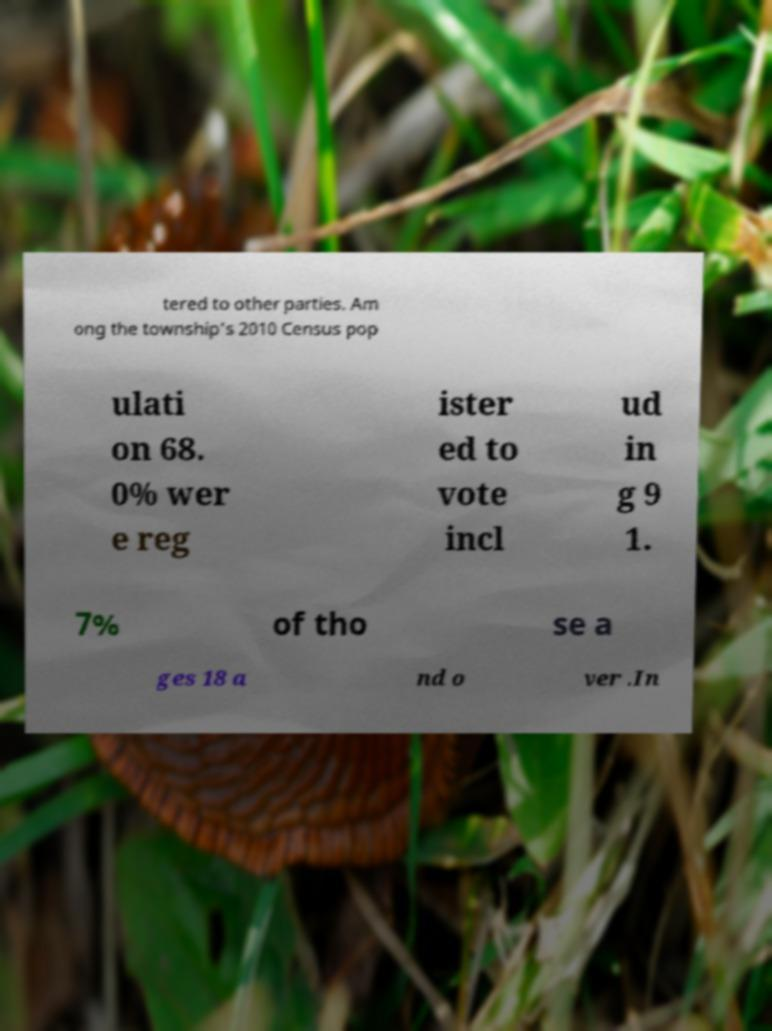Can you accurately transcribe the text from the provided image for me? tered to other parties. Am ong the township's 2010 Census pop ulati on 68. 0% wer e reg ister ed to vote incl ud in g 9 1. 7% of tho se a ges 18 a nd o ver .In 